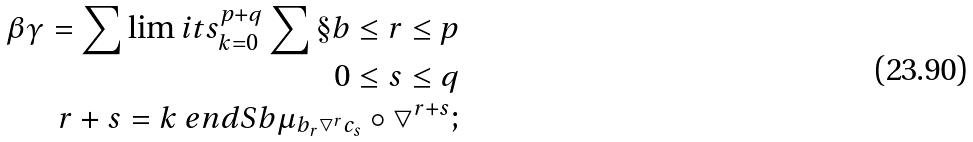Convert formula to latex. <formula><loc_0><loc_0><loc_500><loc_500>\beta \gamma = \sum \lim i t s ^ { p + q } _ { k = 0 } \sum \S b \leq r \leq p \\ 0 \leq s \leq q \\ r + s = k \ e n d S b \mu _ { b _ { r } \bigtriangledown ^ { r } c _ { s } } \circ \bigtriangledown ^ { r + s } ;</formula> 